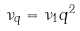Convert formula to latex. <formula><loc_0><loc_0><loc_500><loc_500>\nu _ { q } = \nu _ { 1 } q ^ { 2 }</formula> 